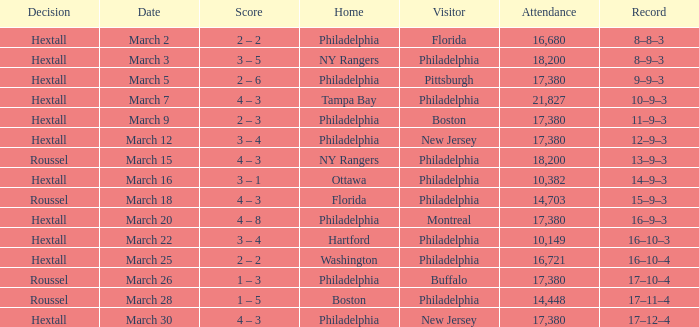I'm looking to parse the entire table for insights. Could you assist me with that? {'header': ['Decision', 'Date', 'Score', 'Home', 'Visitor', 'Attendance', 'Record'], 'rows': [['Hextall', 'March 2', '2 – 2', 'Philadelphia', 'Florida', '16,680', '8–8–3'], ['Hextall', 'March 3', '3 – 5', 'NY Rangers', 'Philadelphia', '18,200', '8–9–3'], ['Hextall', 'March 5', '2 – 6', 'Philadelphia', 'Pittsburgh', '17,380', '9–9–3'], ['Hextall', 'March 7', '4 – 3', 'Tampa Bay', 'Philadelphia', '21,827', '10–9–3'], ['Hextall', 'March 9', '2 – 3', 'Philadelphia', 'Boston', '17,380', '11–9–3'], ['Hextall', 'March 12', '3 – 4', 'Philadelphia', 'New Jersey', '17,380', '12–9–3'], ['Roussel', 'March 15', '4 – 3', 'NY Rangers', 'Philadelphia', '18,200', '13–9–3'], ['Hextall', 'March 16', '3 – 1', 'Ottawa', 'Philadelphia', '10,382', '14–9–3'], ['Roussel', 'March 18', '4 – 3', 'Florida', 'Philadelphia', '14,703', '15–9–3'], ['Hextall', 'March 20', '4 – 8', 'Philadelphia', 'Montreal', '17,380', '16–9–3'], ['Hextall', 'March 22', '3 – 4', 'Hartford', 'Philadelphia', '10,149', '16–10–3'], ['Hextall', 'March 25', '2 – 2', 'Washington', 'Philadelphia', '16,721', '16–10–4'], ['Roussel', 'March 26', '1 – 3', 'Philadelphia', 'Buffalo', '17,380', '17–10–4'], ['Roussel', 'March 28', '1 – 5', 'Boston', 'Philadelphia', '14,448', '17–11–4'], ['Hextall', 'March 30', '4 – 3', 'Philadelphia', 'New Jersey', '17,380', '17–12–4']]} Date of march 30 involves what home? Philadelphia. 